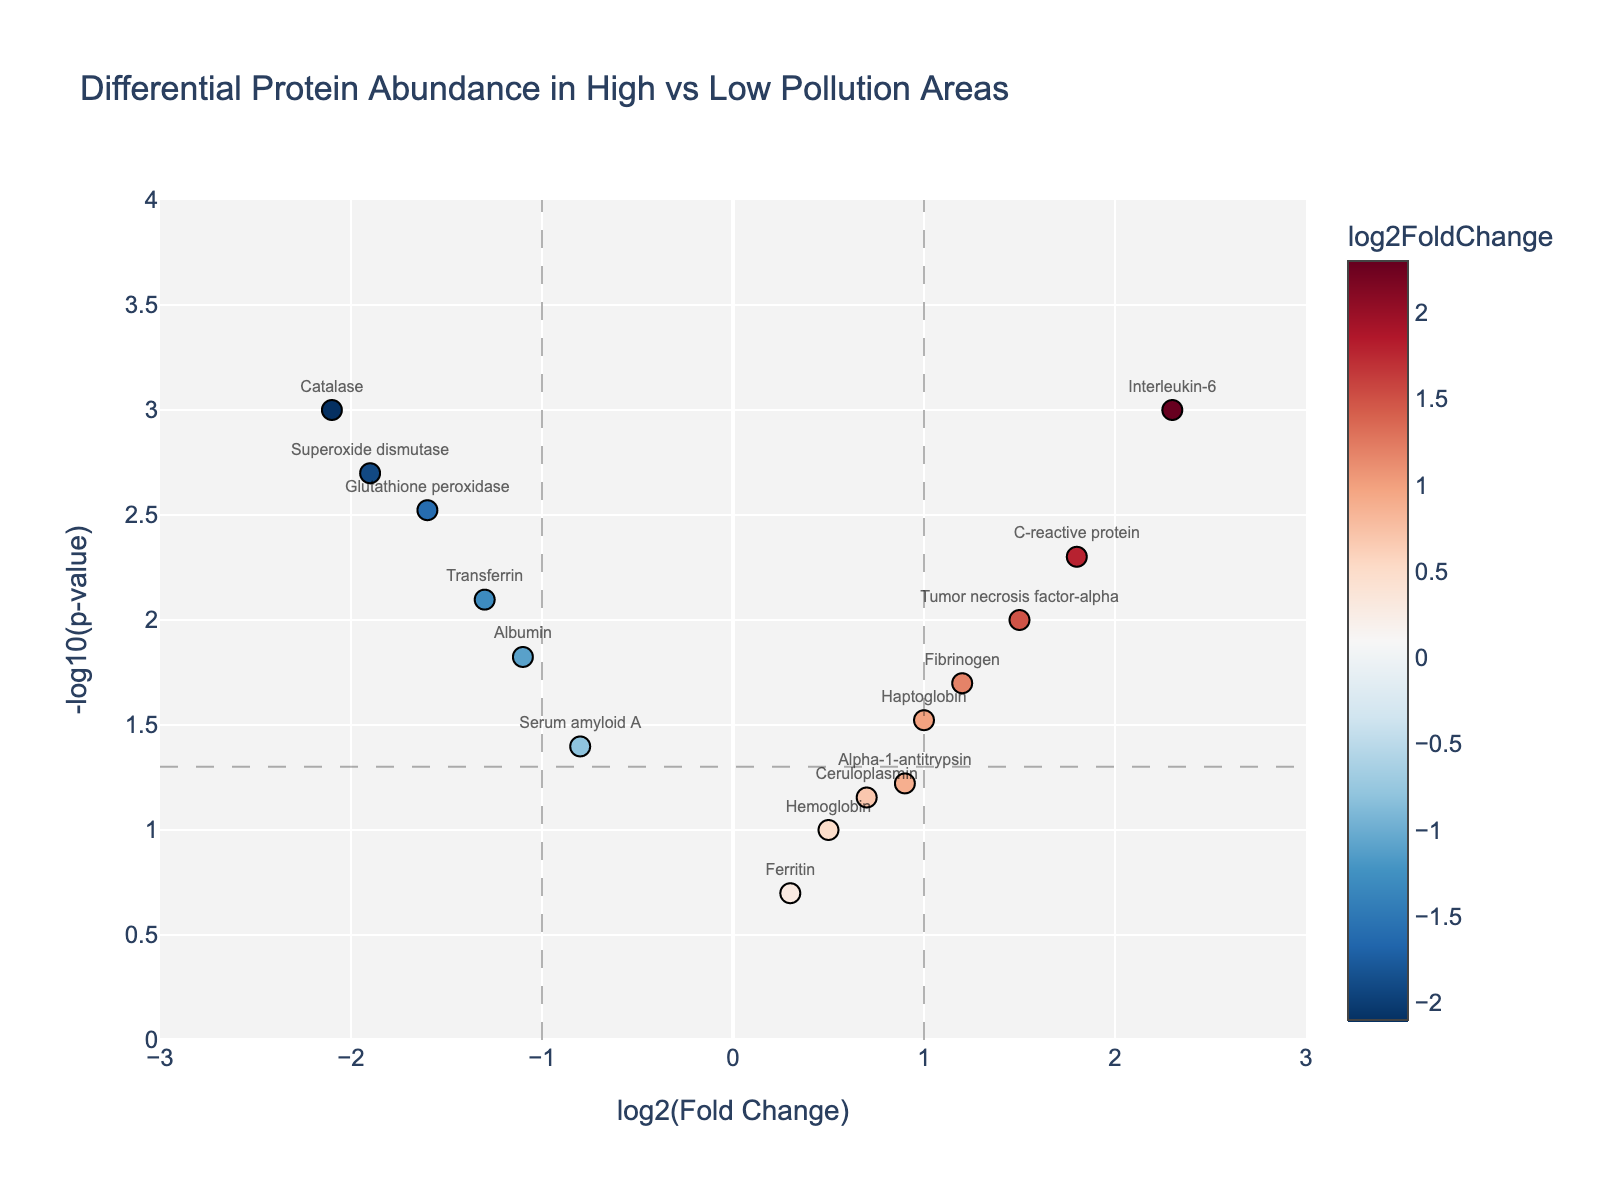What is the title of the figure? The title of the figure is usually displayed at the top. Here, it reads, "Differential Protein Abundance in High vs Low Pollution Areas."
Answer: Differential Protein Abundance in High vs Low Pollution Areas How many data points are there in the figure? By counting the data points (symbols) in the plot, we find there are 15 in total.
Answer: 15 What do the x-axis and y-axis represent? The x-axis is labeled "log2(Fold Change)" and the y-axis is labeled "-log10(p-value)," indicating these are the metrics used in the plot.
Answer: log2(Fold Change) and -log10(p-value) What is the average log2(Fold Change) value for proteins with p-value < 0.01? First, identify proteins with p-value < 0.01: Interleukin-6 (2.3), C-reactive protein (1.8), Tumor necrosis factor-alpha (1.5), Transferrin (-1.3), Glutathione peroxidase (-1.6), Superoxide dismutase (-1.9), and Catalase (-2.1). Sum these values: 2.3 + 1.8 + 1.5 + (-1.3) + (-1.6) + (-1.9) + (-2.1) = -1.3. Divide by the number of data points (7): -1.3 / 7 ≈ -0.19.
Answer: -0.19 Which protein has the highest log2(Fold Change)? By comparing the log2(Fold Change) values from the plot, Interleukin-6 has the highest log2(Fold Change) value of 2.3.
Answer: Interleukin-6 Which protein has the smallest p-value? The smallest p-value corresponds to the largest -log10(p-value). Interleukin-6 and Catalase both have the highest -log10(p-value) which is 3, correlating to a p-value of 0.001 but for clarity, based on alphabetical order Interleukin-6 can be chosen.
Answer: Interleukin-6 Which protein shows a notable decrease in abundance and is statistically significant? Proteins with negative log2(Fold Change) and -log10(p-value) above the threshold line (1.301) are significant. Among them, Catalase (log2FoldChange -2.1, -log10(p-value) = 3.0) shows a notable decrease.
Answer: Catalase What is the threshold p-value depicted on the plot, and what does it signify? The threshold line on the y-axis is at -log10(0.05), which equals 1.301. This line indicates statistical significance, meaning proteins above this line have p-values < 0.05.
Answer: p-value < 0.05 